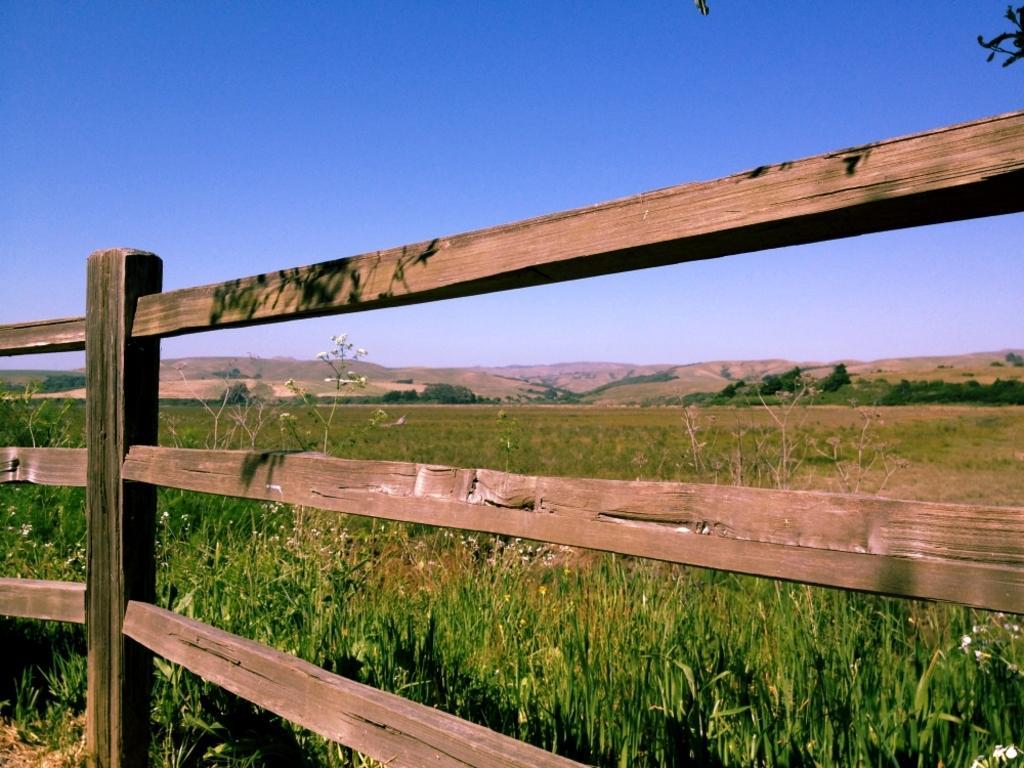Describe this image in one or two sentences. At the bottom of this image, there is a wooden fence. Behind this wooden fence, there are plants. In the background, there are trees, mountains and there are clouds in the blue sky. 